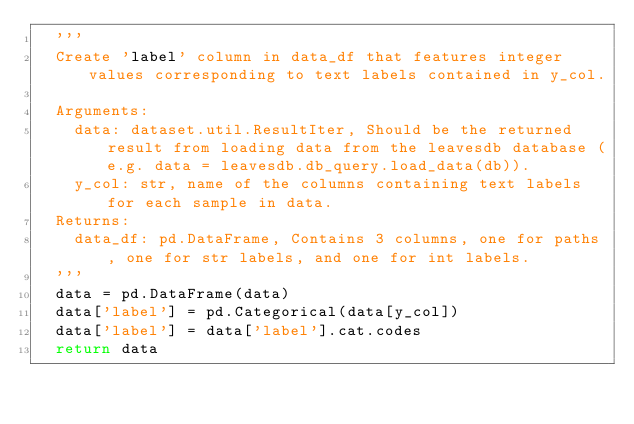<code> <loc_0><loc_0><loc_500><loc_500><_Python_>	'''
	Create 'label' column in data_df that features integer values corresponding to text labels contained in y_col.
	
	Arguments:
		data: dataset.util.ResultIter, Should be the returned result from loading data from the leavesdb database (e.g. data = leavesdb.db_query.load_data(db)).
		y_col: str, name of the columns containing text labels for each sample in data.
	Returns:
		data_df: pd.DataFrame, Contains 3 columns, one for paths, one for str labels, and one for int labels.
	'''
	data = pd.DataFrame(data)
	data['label'] = pd.Categorical(data[y_col])
	data['label'] = data['label'].cat.codes
	return data

</code> 